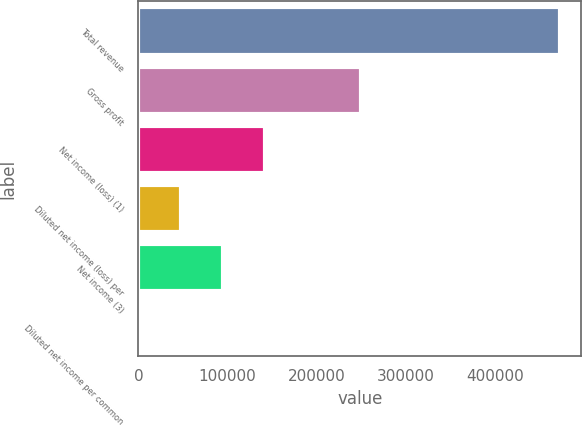Convert chart to OTSL. <chart><loc_0><loc_0><loc_500><loc_500><bar_chart><fcel>Total revenue<fcel>Gross profit<fcel>Net income (loss) (1)<fcel>Diluted net income (loss) per<fcel>Net income (3)<fcel>Diluted net income per common<nl><fcel>472711<fcel>249370<fcel>141813<fcel>47271.1<fcel>94542.2<fcel>0.04<nl></chart> 